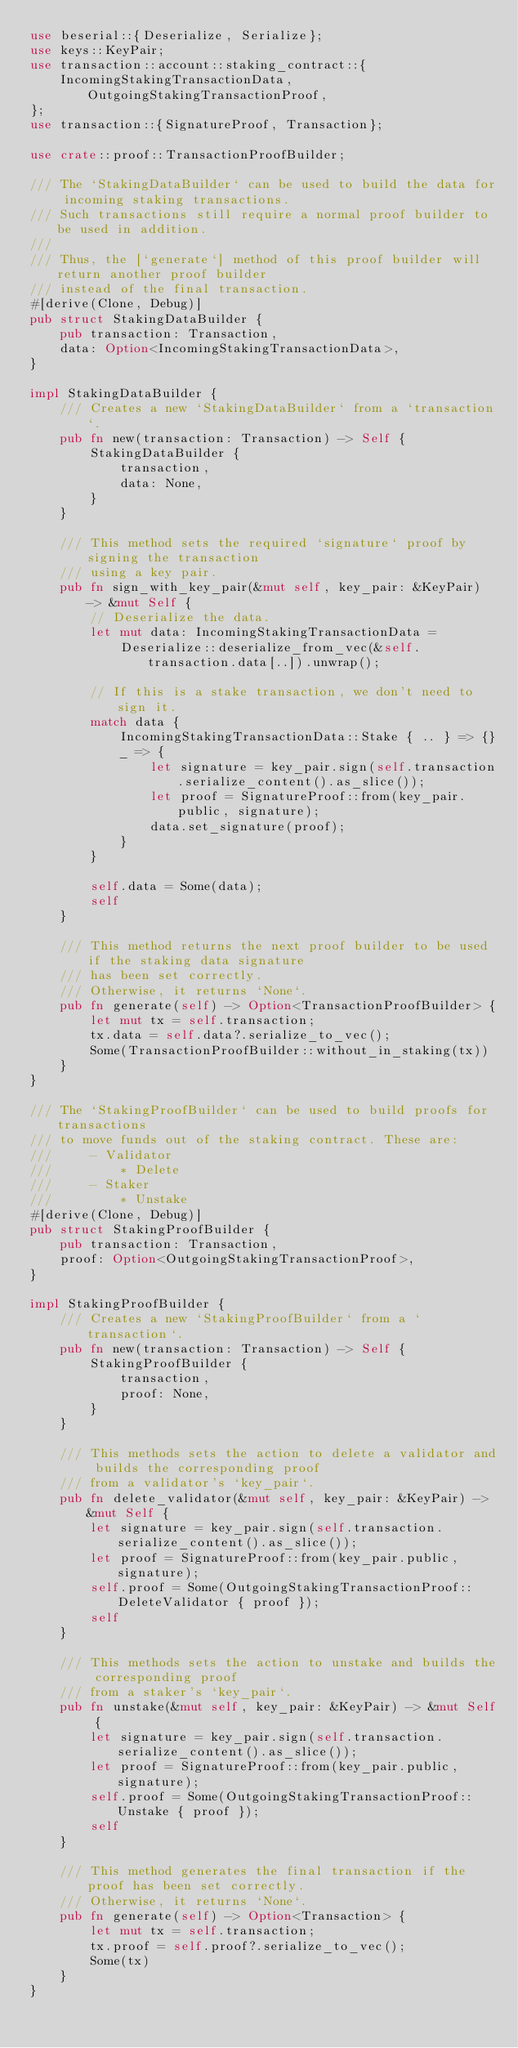Convert code to text. <code><loc_0><loc_0><loc_500><loc_500><_Rust_>use beserial::{Deserialize, Serialize};
use keys::KeyPair;
use transaction::account::staking_contract::{
    IncomingStakingTransactionData, OutgoingStakingTransactionProof,
};
use transaction::{SignatureProof, Transaction};

use crate::proof::TransactionProofBuilder;

/// The `StakingDataBuilder` can be used to build the data for incoming staking transactions.
/// Such transactions still require a normal proof builder to be used in addition.
///
/// Thus, the [`generate`] method of this proof builder will return another proof builder
/// instead of the final transaction.
#[derive(Clone, Debug)]
pub struct StakingDataBuilder {
    pub transaction: Transaction,
    data: Option<IncomingStakingTransactionData>,
}

impl StakingDataBuilder {
    /// Creates a new `StakingDataBuilder` from a `transaction`.
    pub fn new(transaction: Transaction) -> Self {
        StakingDataBuilder {
            transaction,
            data: None,
        }
    }

    /// This method sets the required `signature` proof by signing the transaction
    /// using a key pair.
    pub fn sign_with_key_pair(&mut self, key_pair: &KeyPair) -> &mut Self {
        // Deserialize the data.
        let mut data: IncomingStakingTransactionData =
            Deserialize::deserialize_from_vec(&self.transaction.data[..]).unwrap();

        // If this is a stake transaction, we don't need to sign it.
        match data {
            IncomingStakingTransactionData::Stake { .. } => {}
            _ => {
                let signature = key_pair.sign(self.transaction.serialize_content().as_slice());
                let proof = SignatureProof::from(key_pair.public, signature);
                data.set_signature(proof);
            }
        }

        self.data = Some(data);
        self
    }

    /// This method returns the next proof builder to be used if the staking data signature
    /// has been set correctly.
    /// Otherwise, it returns `None`.
    pub fn generate(self) -> Option<TransactionProofBuilder> {
        let mut tx = self.transaction;
        tx.data = self.data?.serialize_to_vec();
        Some(TransactionProofBuilder::without_in_staking(tx))
    }
}

/// The `StakingProofBuilder` can be used to build proofs for transactions
/// to move funds out of the staking contract. These are:
///     - Validator
///         * Delete
///     - Staker
///         * Unstake
#[derive(Clone, Debug)]
pub struct StakingProofBuilder {
    pub transaction: Transaction,
    proof: Option<OutgoingStakingTransactionProof>,
}

impl StakingProofBuilder {
    /// Creates a new `StakingProofBuilder` from a `transaction`.
    pub fn new(transaction: Transaction) -> Self {
        StakingProofBuilder {
            transaction,
            proof: None,
        }
    }

    /// This methods sets the action to delete a validator and builds the corresponding proof
    /// from a validator's `key_pair`.
    pub fn delete_validator(&mut self, key_pair: &KeyPair) -> &mut Self {
        let signature = key_pair.sign(self.transaction.serialize_content().as_slice());
        let proof = SignatureProof::from(key_pair.public, signature);
        self.proof = Some(OutgoingStakingTransactionProof::DeleteValidator { proof });
        self
    }

    /// This methods sets the action to unstake and builds the corresponding proof
    /// from a staker's `key_pair`.
    pub fn unstake(&mut self, key_pair: &KeyPair) -> &mut Self {
        let signature = key_pair.sign(self.transaction.serialize_content().as_slice());
        let proof = SignatureProof::from(key_pair.public, signature);
        self.proof = Some(OutgoingStakingTransactionProof::Unstake { proof });
        self
    }

    /// This method generates the final transaction if the proof has been set correctly.
    /// Otherwise, it returns `None`.
    pub fn generate(self) -> Option<Transaction> {
        let mut tx = self.transaction;
        tx.proof = self.proof?.serialize_to_vec();
        Some(tx)
    }
}
</code> 